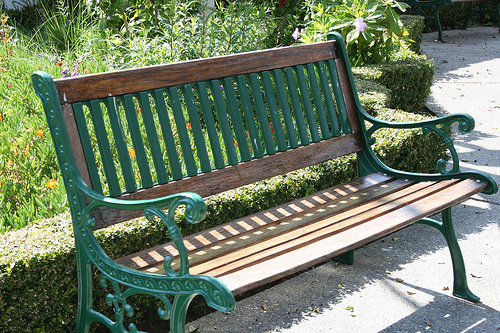What materials is the bench made of? The bench is constructed with a durable cast iron frame, noted for its ornate design, and it is fitted with wooden slats that form the seat and backrest, providing a comfortable seating option in the garden. 